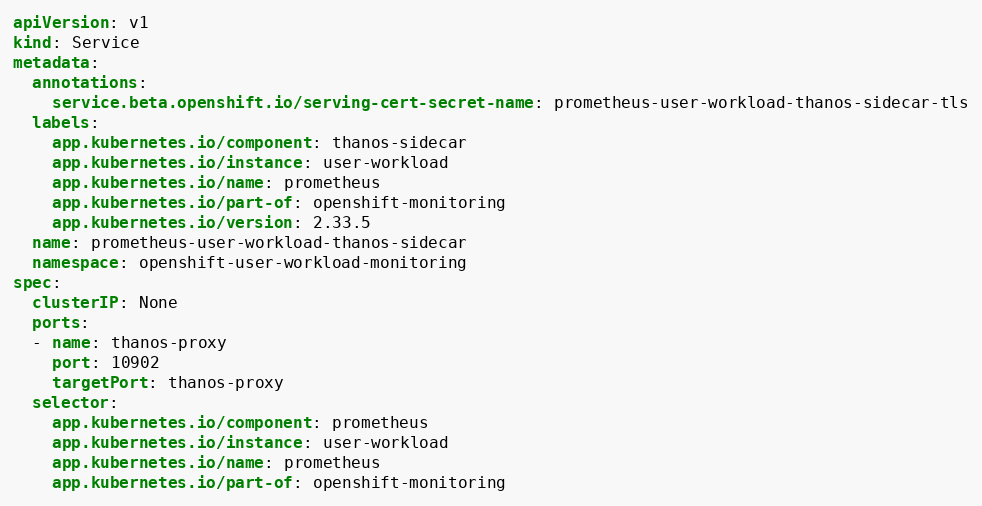Convert code to text. <code><loc_0><loc_0><loc_500><loc_500><_YAML_>apiVersion: v1
kind: Service
metadata:
  annotations:
    service.beta.openshift.io/serving-cert-secret-name: prometheus-user-workload-thanos-sidecar-tls
  labels:
    app.kubernetes.io/component: thanos-sidecar
    app.kubernetes.io/instance: user-workload
    app.kubernetes.io/name: prometheus
    app.kubernetes.io/part-of: openshift-monitoring
    app.kubernetes.io/version: 2.33.5
  name: prometheus-user-workload-thanos-sidecar
  namespace: openshift-user-workload-monitoring
spec:
  clusterIP: None
  ports:
  - name: thanos-proxy
    port: 10902
    targetPort: thanos-proxy
  selector:
    app.kubernetes.io/component: prometheus
    app.kubernetes.io/instance: user-workload
    app.kubernetes.io/name: prometheus
    app.kubernetes.io/part-of: openshift-monitoring
</code> 